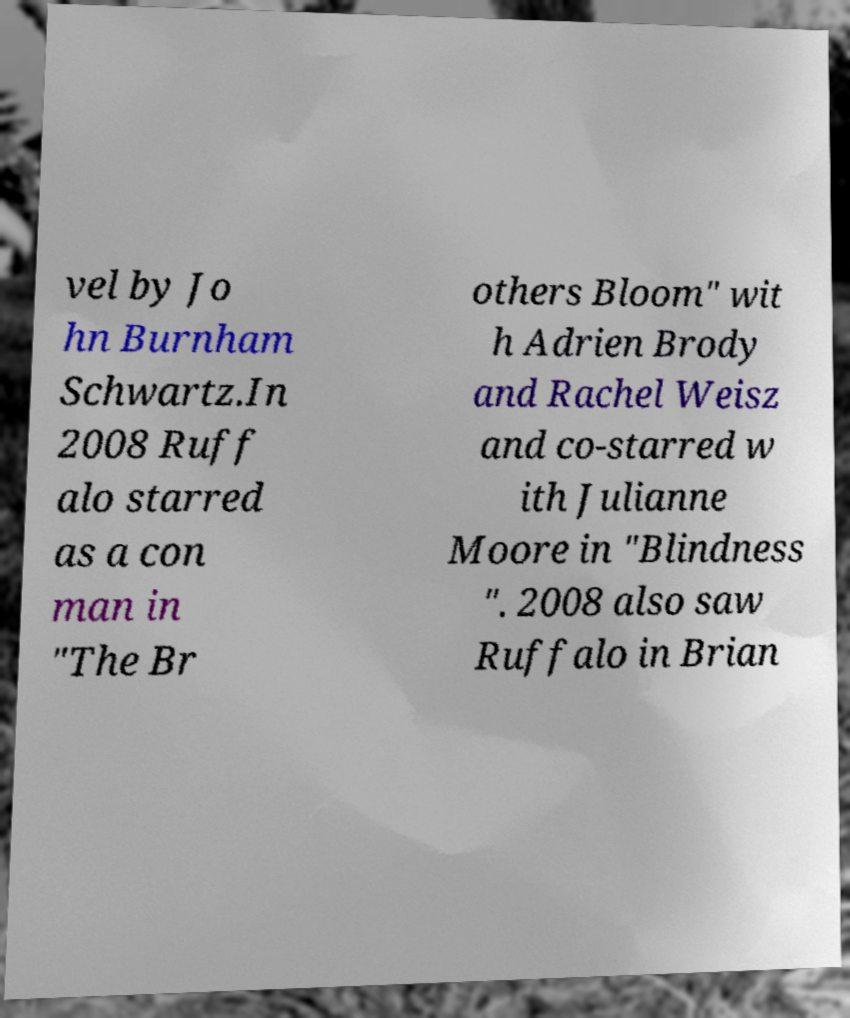Could you extract and type out the text from this image? vel by Jo hn Burnham Schwartz.In 2008 Ruff alo starred as a con man in "The Br others Bloom" wit h Adrien Brody and Rachel Weisz and co-starred w ith Julianne Moore in "Blindness ". 2008 also saw Ruffalo in Brian 